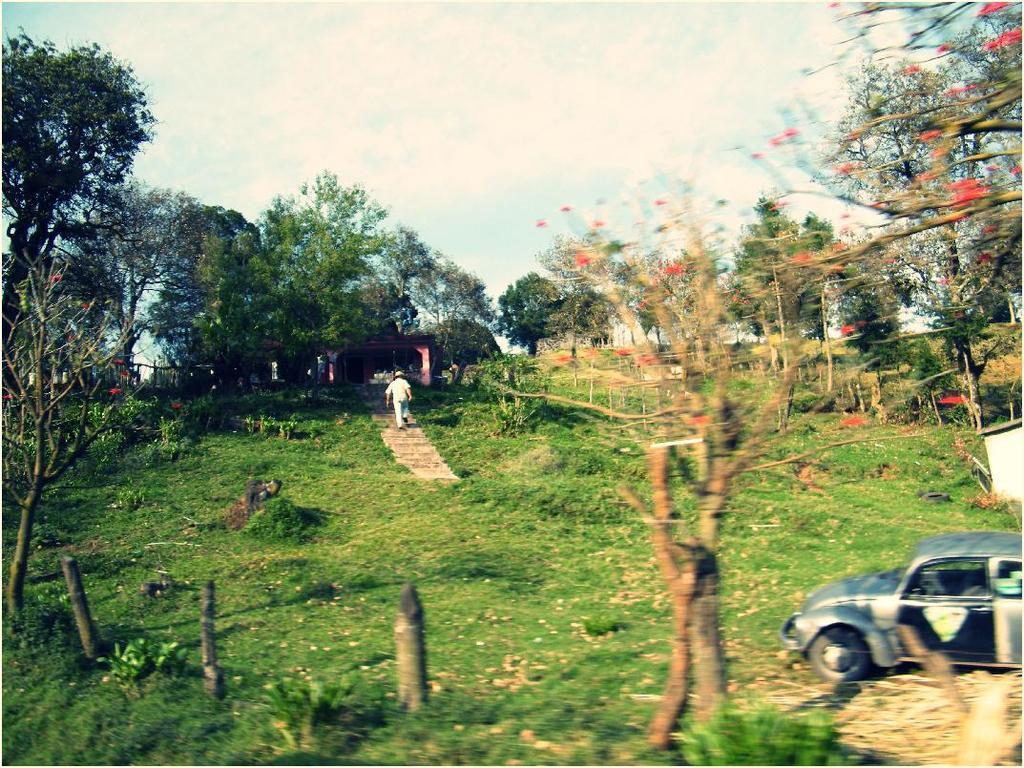In one or two sentences, can you explain what this image depicts? In the picture we can see a garden with grass surface and some plants on it and we can also see a slope with some steps on it, we can see a man is walking and on the grass surface, we can see a car is parked and in the background we can see some trees and sky with clouds. 